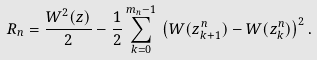<formula> <loc_0><loc_0><loc_500><loc_500>R _ { n } = \frac { W ^ { 2 } ( z ) } { 2 } - \frac { 1 } { 2 } \sum _ { k = 0 } ^ { m _ { n } - 1 } \, \left ( W ( z ^ { n } _ { k + 1 } ) - W ( z ^ { n } _ { k } ) \right ) ^ { 2 } .</formula> 